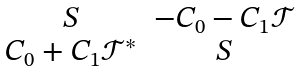Convert formula to latex. <formula><loc_0><loc_0><loc_500><loc_500>\begin{matrix} S & - C _ { 0 } - C _ { 1 } \mathcal { T } \\ C _ { 0 } + C _ { 1 } \mathcal { T } ^ { * } & S \end{matrix}</formula> 